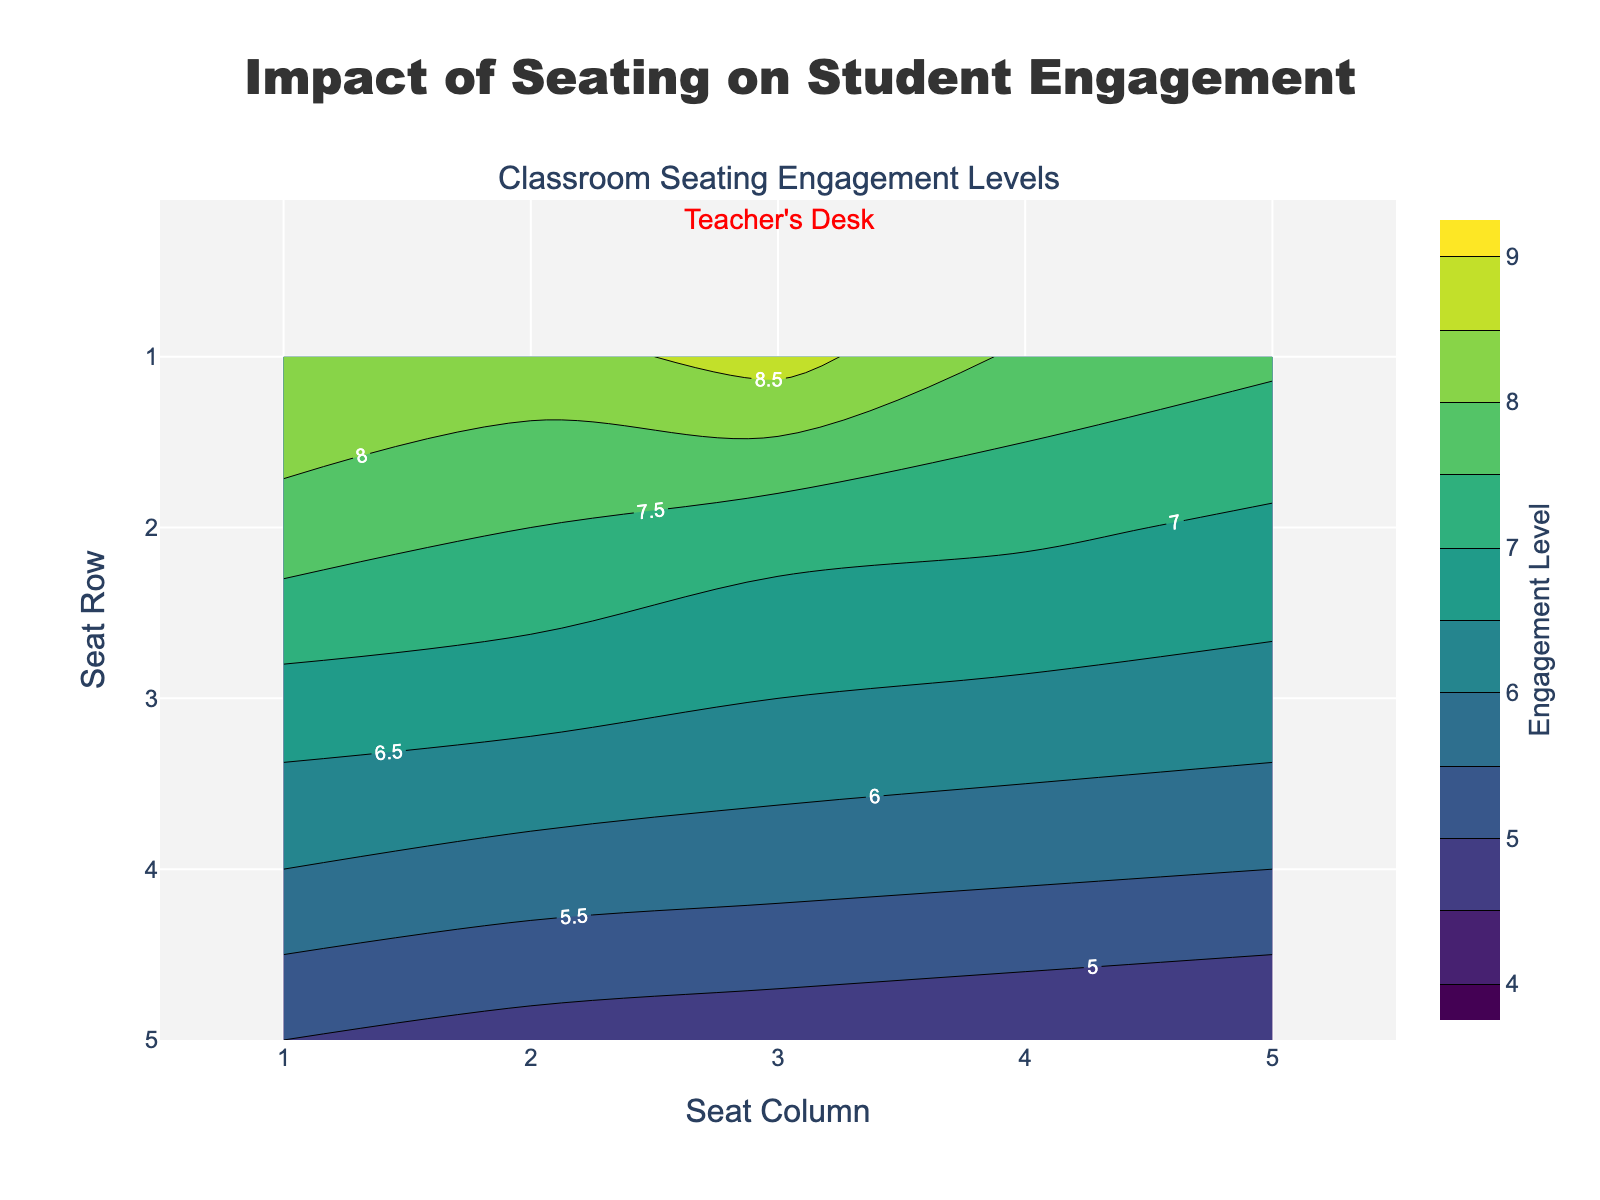What's the title of the figure? The title of the figure is located at the top and reads "Impact of Seating on Student Engagement"
Answer: Impact of Seating on Student Engagement Which seat row seems to have the highest engagement level? By looking at the contour plot, the topmost row, row 1, has the highest engagement levels as indicated by the darker colors and contour lines indicating values around 8.5
Answer: Row 1 What is the engagement level of the seat at row 3, column 2? According to the contour plot and the data points, the seat located at row 3, column 2 has an engagement level of 6.7
Answer: 6.7 How does the engagement level change as you move from row 1 to row 5 in column 3? The contour plot shows a decrease in engagement levels as you move from row 1 to row 5 in column 3. The values go from 8.7 to 4.7
Answer: Decreases In which rows are the engagement levels above 8.0? By observing the contour plot, the rows with engagement levels above 8.0 are row 1 and possibly parts of row 2. These high values are marked with the darkest colors.
Answer: Rows 1 and 2 Compare the engagement levels in seat column 1 across all rows. Which row has the lowest engagement level? The contour plot shows the engagement levels in column 1 decreasing from row 1 down to row 5. The lowest engagement level is in row 5 with a level of 5.0
Answer: Row 5 What pattern can be observed regarding the proximity to the teacher's desk and engagement levels? The contour plot indicates that as seats get farther from the teacher’s desk (assumed to be near row 1), the engagement levels generally decrease. This is shown by the color gradient from darker to lighter as you move down the rows
Answer: Engagement decreases with distance from the teacher's desk Is there a significant difference in engagement levels between seats in the center and the sides of the classroom? The contour plot reveals that the central columns (2 and 3) have slightly higher engagement levels compared to the side columns (1 and 5). This trend is evident in the mid-range z-values
Answer: Yes, center seats have higher engagement What is the engagement level range displayed in the contour plot? The contour plot’s color bar indicates that the engagement levels range from 4.5 to 8.7
Answer: 4.5 to 8.7 